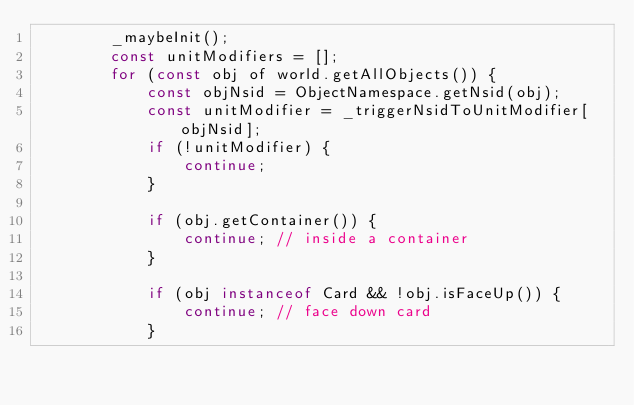<code> <loc_0><loc_0><loc_500><loc_500><_JavaScript_>        _maybeInit();
        const unitModifiers = [];
        for (const obj of world.getAllObjects()) {
            const objNsid = ObjectNamespace.getNsid(obj);
            const unitModifier = _triggerNsidToUnitModifier[objNsid];
            if (!unitModifier) {
                continue;
            }

            if (obj.getContainer()) {
                continue; // inside a container
            }

            if (obj instanceof Card && !obj.isFaceUp()) {
                continue; // face down card
            }
</code> 